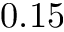<formula> <loc_0><loc_0><loc_500><loc_500>0 . 1 5</formula> 